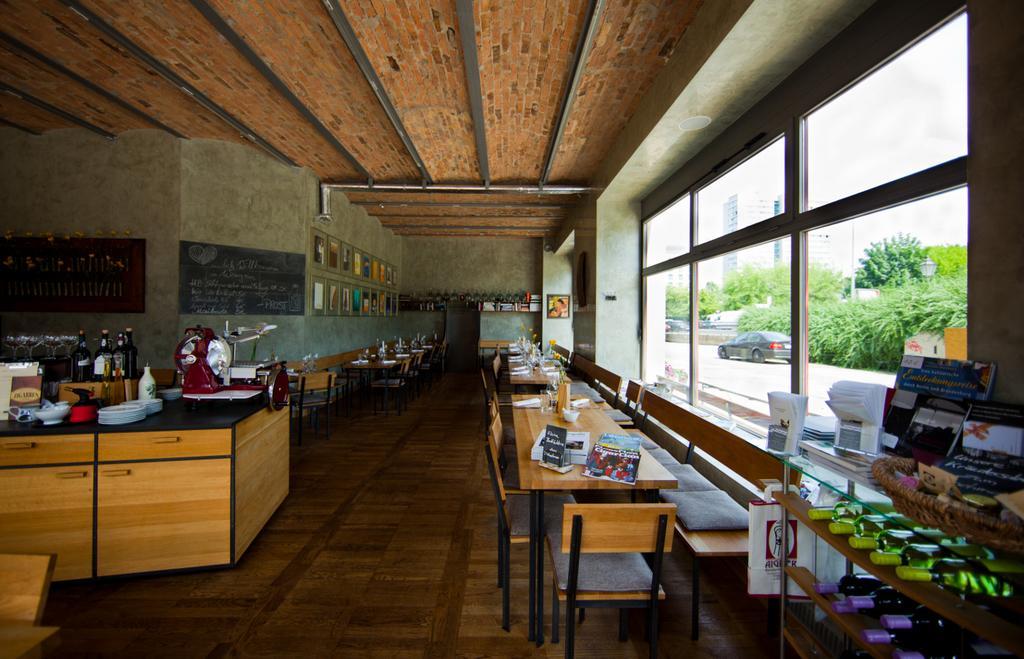Can you describe this image briefly? In this picture there is a kitchen set over here there are some wine Bottles And there is a table some chairs 